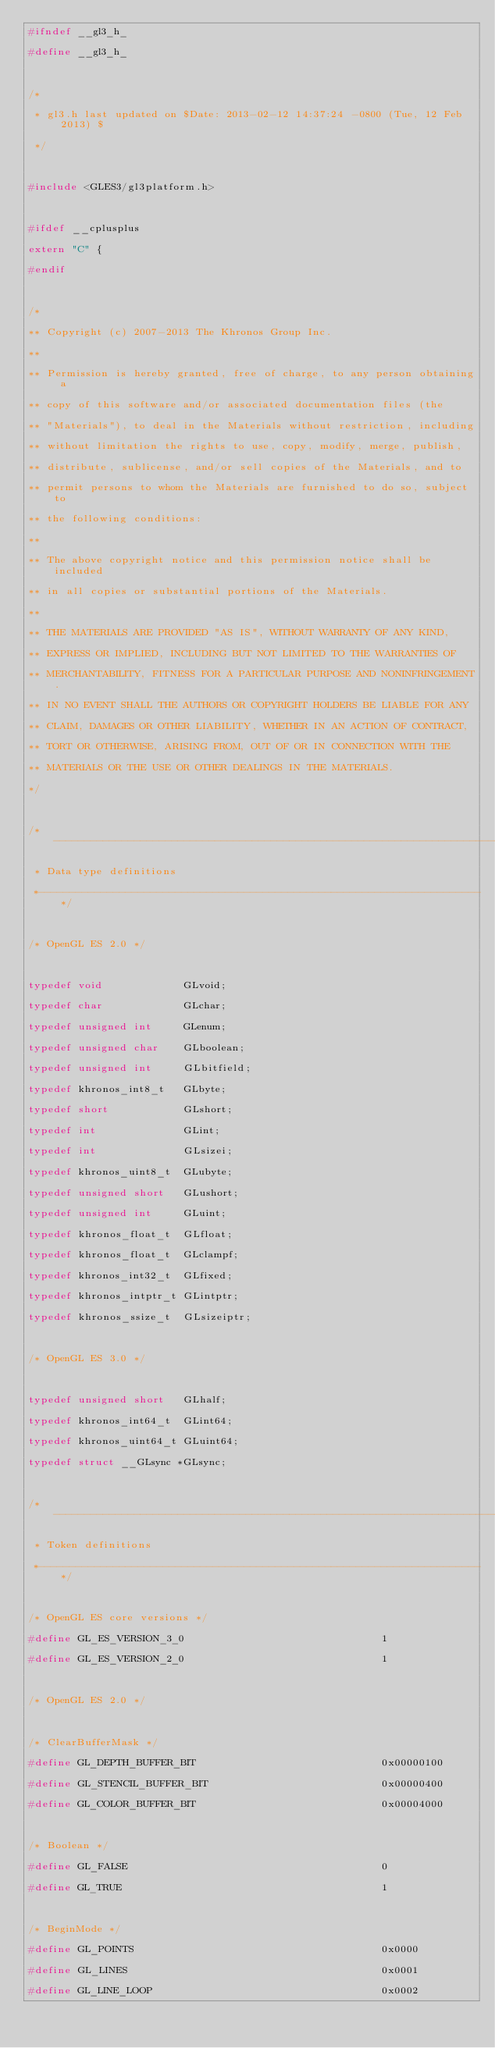Convert code to text. <code><loc_0><loc_0><loc_500><loc_500><_C_>#ifndef __gl3_h_
#define __gl3_h_

/* 
 * gl3.h last updated on $Date: 2013-02-12 14:37:24 -0800 (Tue, 12 Feb 2013) $
 */

#include <GLES3/gl3platform.h>

#ifdef __cplusplus
extern "C" {
#endif

/*
** Copyright (c) 2007-2013 The Khronos Group Inc.
**
** Permission is hereby granted, free of charge, to any person obtaining a
** copy of this software and/or associated documentation files (the
** "Materials"), to deal in the Materials without restriction, including
** without limitation the rights to use, copy, modify, merge, publish,
** distribute, sublicense, and/or sell copies of the Materials, and to
** permit persons to whom the Materials are furnished to do so, subject to
** the following conditions:
**
** The above copyright notice and this permission notice shall be included
** in all copies or substantial portions of the Materials.
**
** THE MATERIALS ARE PROVIDED "AS IS", WITHOUT WARRANTY OF ANY KIND,
** EXPRESS OR IMPLIED, INCLUDING BUT NOT LIMITED TO THE WARRANTIES OF
** MERCHANTABILITY, FITNESS FOR A PARTICULAR PURPOSE AND NONINFRINGEMENT.
** IN NO EVENT SHALL THE AUTHORS OR COPYRIGHT HOLDERS BE LIABLE FOR ANY
** CLAIM, DAMAGES OR OTHER LIABILITY, WHETHER IN AN ACTION OF CONTRACT,
** TORT OR OTHERWISE, ARISING FROM, OUT OF OR IN CONNECTION WITH THE
** MATERIALS OR THE USE OR OTHER DEALINGS IN THE MATERIALS.
*/

/*-------------------------------------------------------------------------
 * Data type definitions
 *-----------------------------------------------------------------------*/

/* OpenGL ES 2.0 */

typedef void             GLvoid;
typedef char             GLchar;
typedef unsigned int     GLenum;
typedef unsigned char    GLboolean;
typedef unsigned int     GLbitfield;
typedef khronos_int8_t   GLbyte;
typedef short            GLshort;
typedef int              GLint;
typedef int              GLsizei;
typedef khronos_uint8_t  GLubyte;
typedef unsigned short   GLushort;
typedef unsigned int     GLuint;
typedef khronos_float_t  GLfloat;
typedef khronos_float_t  GLclampf;
typedef khronos_int32_t  GLfixed;
typedef khronos_intptr_t GLintptr;
typedef khronos_ssize_t  GLsizeiptr;

/* OpenGL ES 3.0 */

typedef unsigned short   GLhalf;
typedef khronos_int64_t  GLint64;
typedef khronos_uint64_t GLuint64;
typedef struct __GLsync *GLsync;

/*-------------------------------------------------------------------------
 * Token definitions
 *-----------------------------------------------------------------------*/

/* OpenGL ES core versions */
#define GL_ES_VERSION_3_0                                1
#define GL_ES_VERSION_2_0                                1

/* OpenGL ES 2.0 */

/* ClearBufferMask */
#define GL_DEPTH_BUFFER_BIT                              0x00000100
#define GL_STENCIL_BUFFER_BIT                            0x00000400
#define GL_COLOR_BUFFER_BIT                              0x00004000

/* Boolean */
#define GL_FALSE                                         0
#define GL_TRUE                                          1

/* BeginMode */
#define GL_POINTS                                        0x0000
#define GL_LINES                                         0x0001
#define GL_LINE_LOOP                                     0x0002</code> 